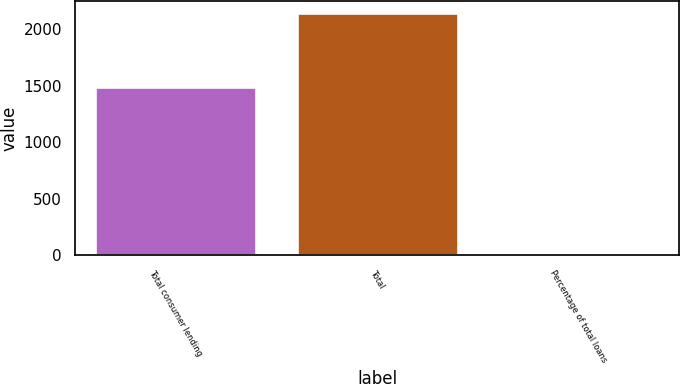Convert chart to OTSL. <chart><loc_0><loc_0><loc_500><loc_500><bar_chart><fcel>Total consumer lending<fcel>Total<fcel>Percentage of total loans<nl><fcel>1489<fcel>2144<fcel>1.02<nl></chart> 